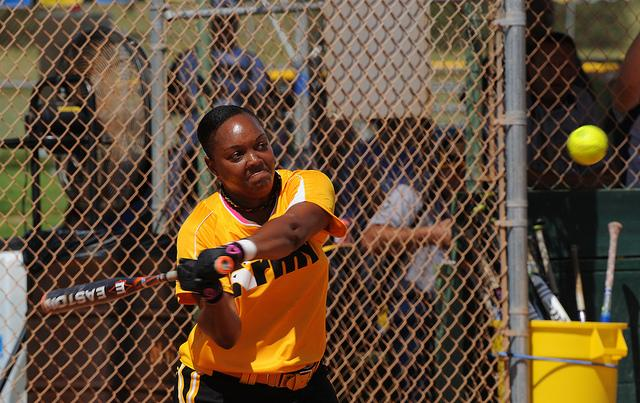Judging by the batters expression how hard is she swinging the bat? Please explain your reasoning. very hard. She has a look of concentration on her face and is trying to get the ball to go as far as possible. 